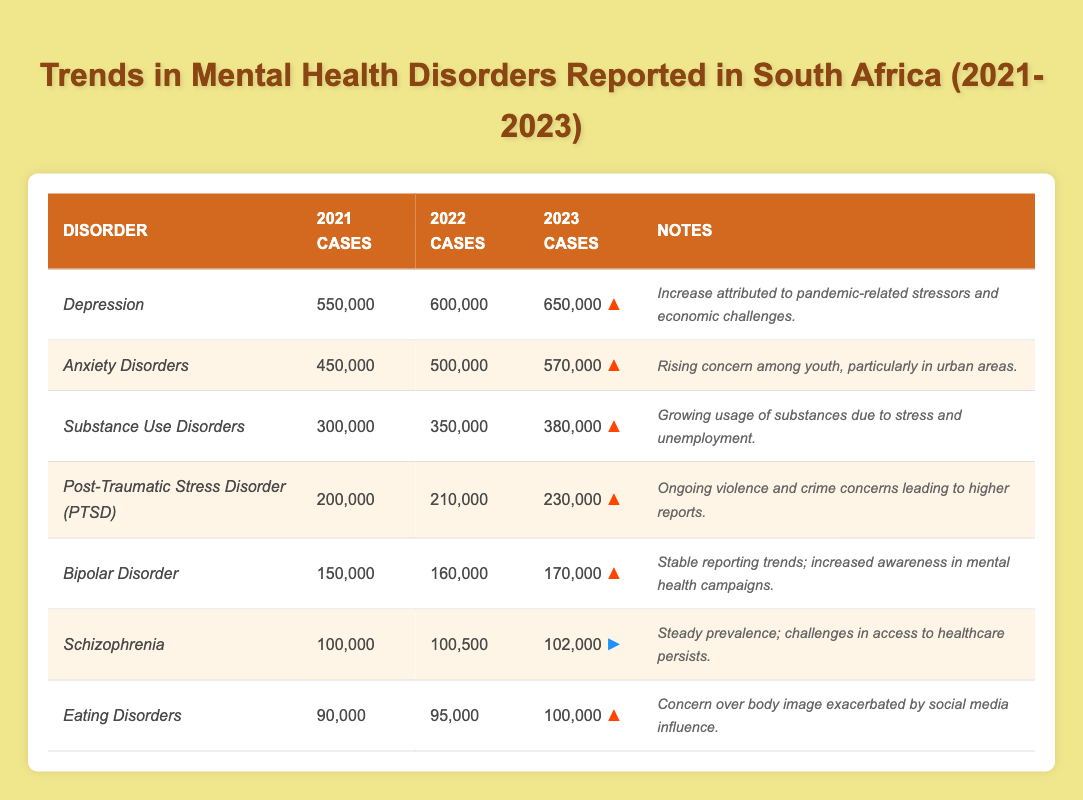What was the reported case number for *Anxiety Disorders* in 2022? According to the table, the reported cases for *Anxiety Disorders* in 2022 are 500,000.
Answer: 500,000 How many more cases of *Depression* were reported in 2023 compared to 2021? The reported cases of *Depression* in 2023 are 650,000 and in 2021 are 550,000. Therefore, the difference is 650,000 - 550,000 = 100,000.
Answer: 100,000 Is it true that reported cases of *Schizophrenia* increased every year from 2021 to 2023? Looking at the reported cases, *Schizophrenia* reported 100,000 in 2021, 100,500 in 2022, and 102,000 in 2023, which shows an increase each year.
Answer: Yes What is the total number of reported cases for *Post-Traumatic Stress Disorder (PTSD)* over the three years? The reported cases of *PTSD* are 200,000 in 2021, 210,000 in 2022, and 230,000 in 2023. Adding these: 200,000 + 210,000 + 230,000 = 640,000.
Answer: 640,000 Which disorder had the highest number of reported cases in 2023? The table indicates that *Depression* had the highest number of reported cases in 2023, with 650,000 cases.
Answer: *Depression* What is the average number of reported cases for *Eating Disorders* across the three years? The reported cases for *Eating Disorders* are 90,000 in 2021, 95,000 in 2022, and 100,000 in 2023. The average is calculated as (90,000 + 95,000 + 100,000) / 3 = 285,000 / 3 = 95,000.
Answer: 95,000 How many cases of *Substance Use Disorders* were reported in 2022? The reported cases of *Substance Use Disorders* in 2022 are clearly listed in the table as 350,000.
Answer: 350,000 Which disorder shows the smallest increase in reported cases from 2021 to 2023? Calculating the increase for each disorder, *Bipolar Disorder* shows an increase from 150,000 to 170,000, which is 20,000, the smallest increase among all listed.
Answer: *Bipolar Disorder* What percentage increase does *Anxiety Disorders* show from 2021 to 2023? The reported cases for *Anxiety Disorders* are 450,000 in 2021 and 570,000 in 2023. The increase is 570,000 - 450,000 = 120,000. The percentage increase is (120,000 / 450,000) * 100 = 26.67%, approximately.
Answer: 26.67% What is the trend observed for *Eating Disorders* from 2021 to 2023? The cases of *Eating Disorders* increased from 90,000 in 2021 to 100,000 in 2023, indicating an upward trend and concern over body image issues, as noted in the table.
Answer: Upward trend Is there a steady increase in reported cases for *Schizophrenia* over the three years? The reported cases for *Schizophrenia* are 100,000 in 2021, 100,500 in 2022, and 102,000 in 2023, which shows a steady increase each year.
Answer: Yes 